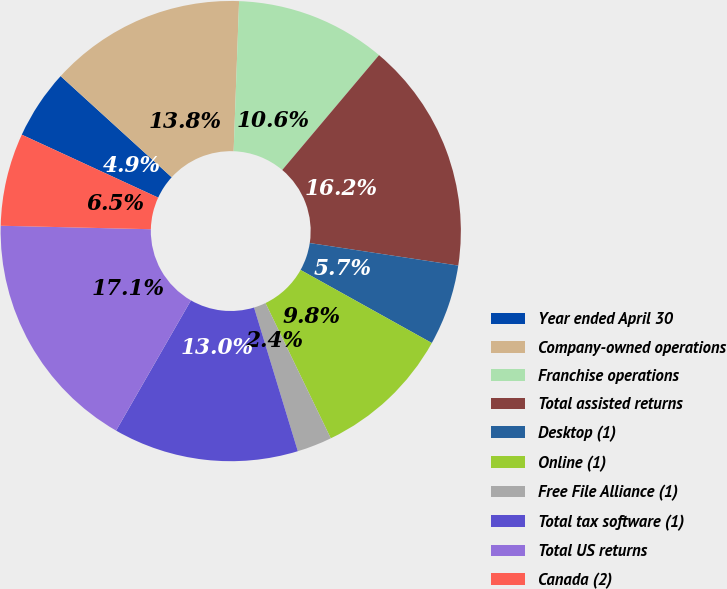Convert chart to OTSL. <chart><loc_0><loc_0><loc_500><loc_500><pie_chart><fcel>Year ended April 30<fcel>Company-owned operations<fcel>Franchise operations<fcel>Total assisted returns<fcel>Desktop (1)<fcel>Online (1)<fcel>Free File Alliance (1)<fcel>Total tax software (1)<fcel>Total US returns<fcel>Canada (2)<nl><fcel>4.88%<fcel>13.82%<fcel>10.57%<fcel>16.25%<fcel>5.69%<fcel>9.76%<fcel>2.45%<fcel>13.01%<fcel>17.07%<fcel>6.51%<nl></chart> 